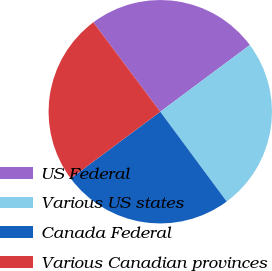Convert chart to OTSL. <chart><loc_0><loc_0><loc_500><loc_500><pie_chart><fcel>US Federal<fcel>Various US states<fcel>Canada Federal<fcel>Various Canadian provinces<nl><fcel>25.04%<fcel>25.05%<fcel>24.95%<fcel>24.96%<nl></chart> 